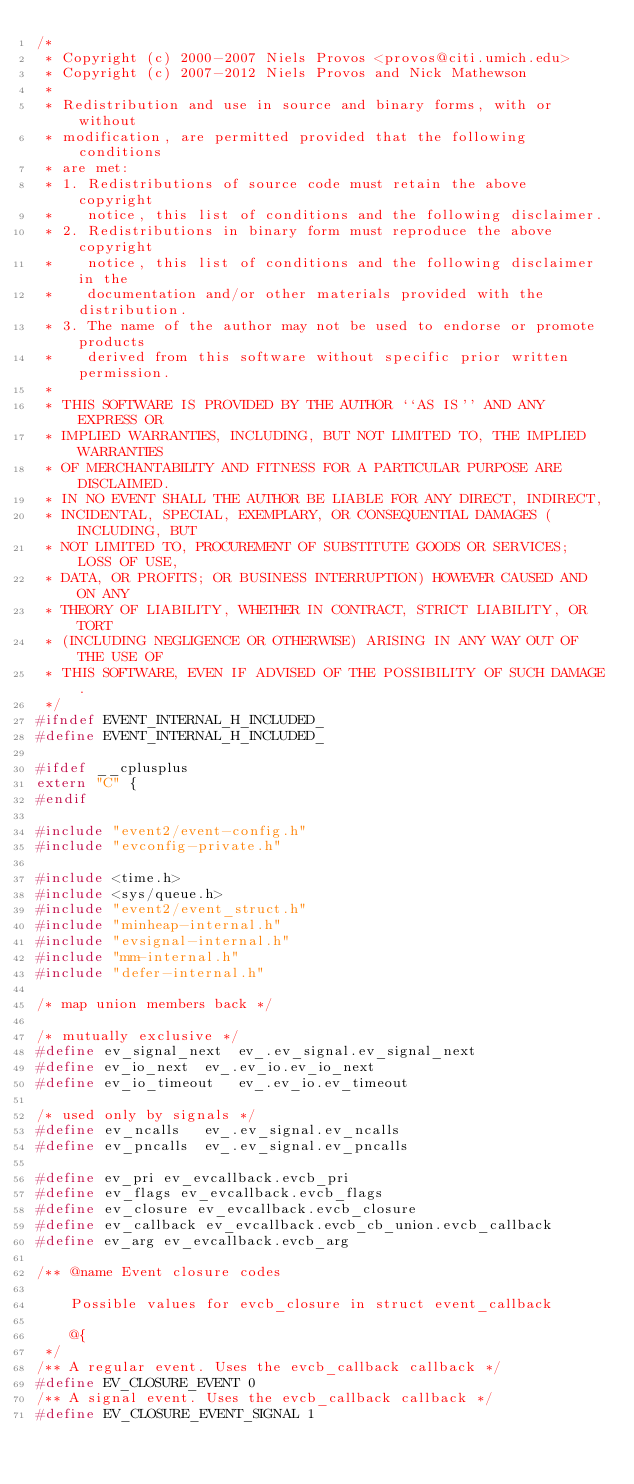<code> <loc_0><loc_0><loc_500><loc_500><_C_>/*
 * Copyright (c) 2000-2007 Niels Provos <provos@citi.umich.edu>
 * Copyright (c) 2007-2012 Niels Provos and Nick Mathewson
 *
 * Redistribution and use in source and binary forms, with or without
 * modification, are permitted provided that the following conditions
 * are met:
 * 1. Redistributions of source code must retain the above copyright
 *    notice, this list of conditions and the following disclaimer.
 * 2. Redistributions in binary form must reproduce the above copyright
 *    notice, this list of conditions and the following disclaimer in the
 *    documentation and/or other materials provided with the distribution.
 * 3. The name of the author may not be used to endorse or promote products
 *    derived from this software without specific prior written permission.
 *
 * THIS SOFTWARE IS PROVIDED BY THE AUTHOR ``AS IS'' AND ANY EXPRESS OR
 * IMPLIED WARRANTIES, INCLUDING, BUT NOT LIMITED TO, THE IMPLIED WARRANTIES
 * OF MERCHANTABILITY AND FITNESS FOR A PARTICULAR PURPOSE ARE DISCLAIMED.
 * IN NO EVENT SHALL THE AUTHOR BE LIABLE FOR ANY DIRECT, INDIRECT,
 * INCIDENTAL, SPECIAL, EXEMPLARY, OR CONSEQUENTIAL DAMAGES (INCLUDING, BUT
 * NOT LIMITED TO, PROCUREMENT OF SUBSTITUTE GOODS OR SERVICES; LOSS OF USE,
 * DATA, OR PROFITS; OR BUSINESS INTERRUPTION) HOWEVER CAUSED AND ON ANY
 * THEORY OF LIABILITY, WHETHER IN CONTRACT, STRICT LIABILITY, OR TORT
 * (INCLUDING NEGLIGENCE OR OTHERWISE) ARISING IN ANY WAY OUT OF THE USE OF
 * THIS SOFTWARE, EVEN IF ADVISED OF THE POSSIBILITY OF SUCH DAMAGE.
 */
#ifndef EVENT_INTERNAL_H_INCLUDED_
#define EVENT_INTERNAL_H_INCLUDED_

#ifdef __cplusplus
extern "C" {
#endif

#include "event2/event-config.h"
#include "evconfig-private.h"

#include <time.h>
#include <sys/queue.h>
#include "event2/event_struct.h"
#include "minheap-internal.h"
#include "evsignal-internal.h"
#include "mm-internal.h"
#include "defer-internal.h"

/* map union members back */

/* mutually exclusive */
#define ev_signal_next	ev_.ev_signal.ev_signal_next
#define ev_io_next	ev_.ev_io.ev_io_next
#define ev_io_timeout	ev_.ev_io.ev_timeout

/* used only by signals */
#define ev_ncalls	ev_.ev_signal.ev_ncalls
#define ev_pncalls	ev_.ev_signal.ev_pncalls

#define ev_pri ev_evcallback.evcb_pri
#define ev_flags ev_evcallback.evcb_flags
#define ev_closure ev_evcallback.evcb_closure
#define ev_callback ev_evcallback.evcb_cb_union.evcb_callback
#define ev_arg ev_evcallback.evcb_arg

/** @name Event closure codes

    Possible values for evcb_closure in struct event_callback

    @{
 */
/** A regular event. Uses the evcb_callback callback */
#define EV_CLOSURE_EVENT 0
/** A signal event. Uses the evcb_callback callback */
#define EV_CLOSURE_EVENT_SIGNAL 1</code> 